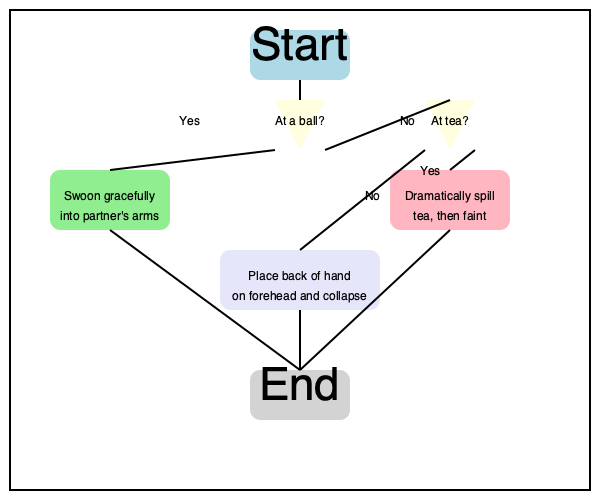In the flowchart depicting the proper etiquette for fainting dramatically in various social situations, what is the recommended course of action if one finds oneself neither at a ball nor at tea? Let us embark upon a journey through this most enlightening flowchart, dear reader:

1. We commence at the "Start" node, our point of departure in this grand adventure of swooning.

2. We are first presented with a query most pressing: "At a ball?" If one responds in the affirmative, we are directed to "Swoon gracefully into partner's arms." How utterly romantic!

3. Should we not be twirling at a ball, we proceed to the next inquiry: "At tea?" If this proves true, we are instructed to "Dramatically spill tea, then faint." A waste of good Earl Grey, to be sure, but oh so theatrical!

4. However, if we find ourselves in neither of these genteel situations, we follow the path that leads us to the default action. This, dear friends, is where we discover our answer.

5. The flowchart dictates that in all other circumstances, one must "Place back of hand on forehead and collapse." A classic maneuver, timeless in its simplicity and effectiveness.

6. From any of these three outcomes, we gracefully glide to the "End" node, having successfully navigated the perilous waters of dramatic fainting.

Thus, we conclude that when neither at a ball nor at tea, one must resort to the time-honored tradition of the hand-to-forehead collapse.
Answer: Place back of hand on forehead and collapse 